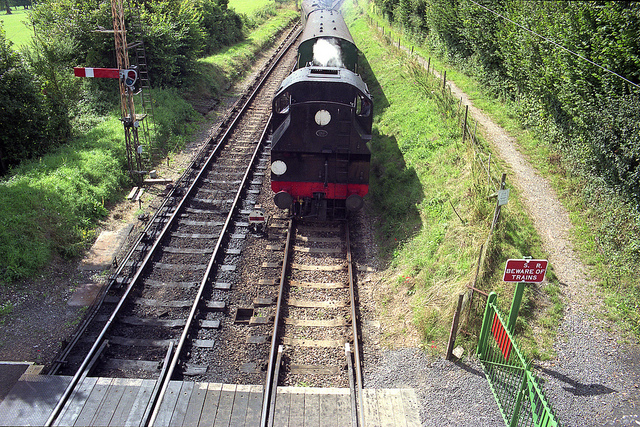Please transcribe the text in this image. DEWARE or TRAINS S R 